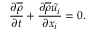Convert formula to latex. <formula><loc_0><loc_0><loc_500><loc_500>{ \frac { \partial { \overline { \rho } } } { \partial t } } + { \frac { \partial { \overline { \rho } } { \tilde { u _ { i } } } } { \partial x _ { i } } } = 0 .</formula> 